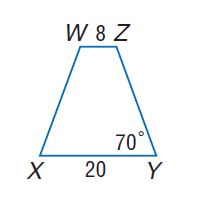Answer the mathemtical geometry problem and directly provide the correct option letter.
Question: For isosceles trapezoid X Y Z W, find the length of the median.
Choices: A: 14 B: 16 C: 28 D: 32 A 